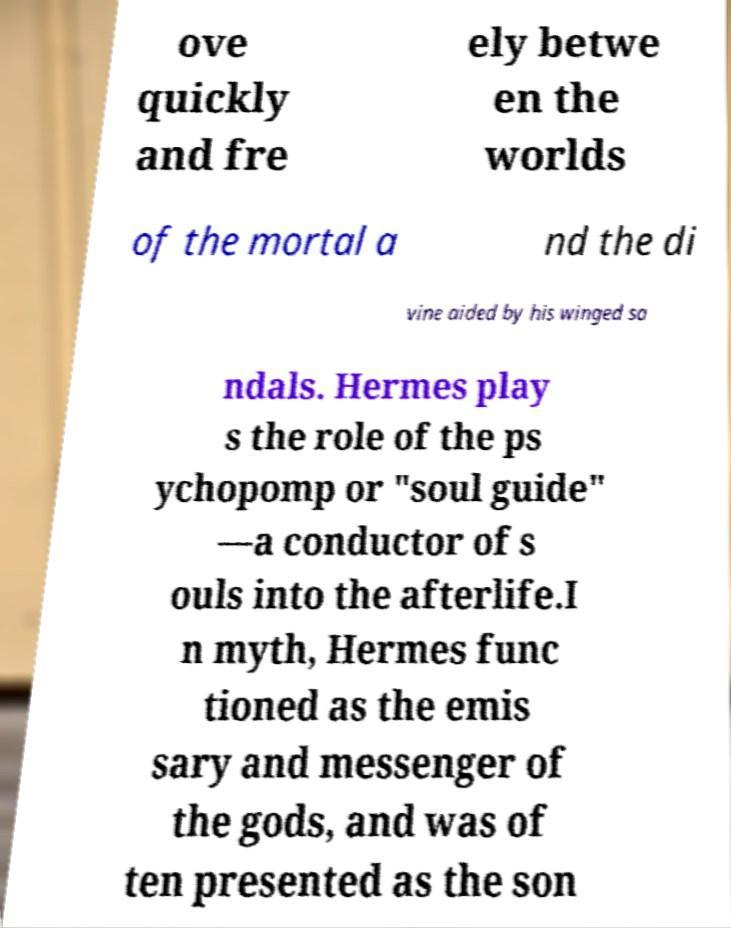Please read and relay the text visible in this image. What does it say? ove quickly and fre ely betwe en the worlds of the mortal a nd the di vine aided by his winged sa ndals. Hermes play s the role of the ps ychopomp or "soul guide" —a conductor of s ouls into the afterlife.I n myth, Hermes func tioned as the emis sary and messenger of the gods, and was of ten presented as the son 